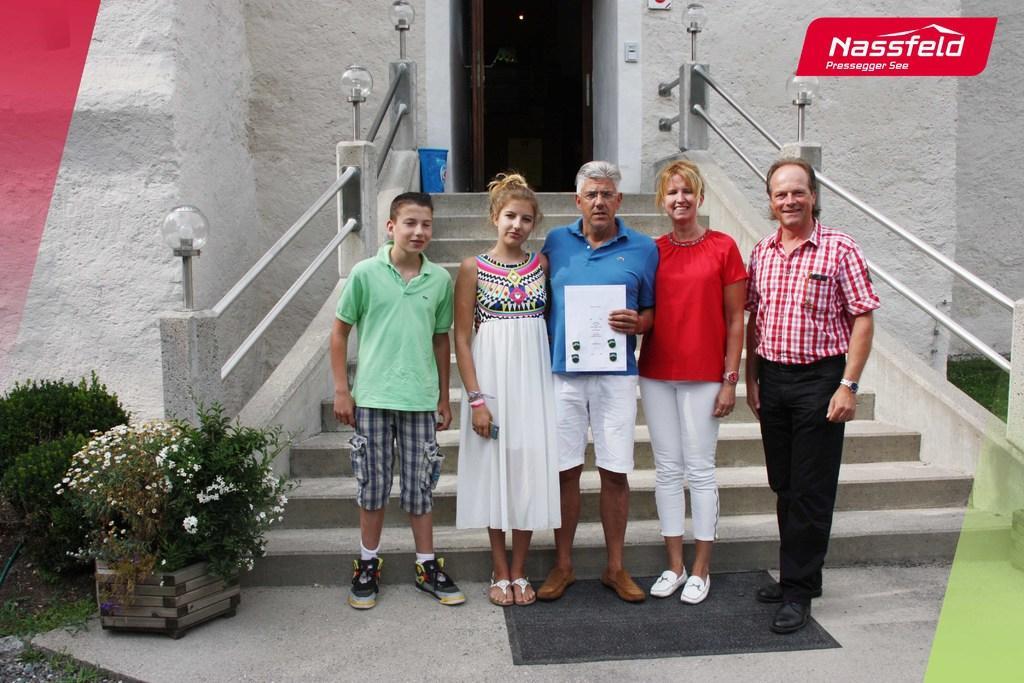Please provide a concise description of this image. In this picture we can see there are five people standing on the floor and a man is holding a paper. Behind the people there are steps, a door and a wall. On the left side of the people there are plants and on the image there is a watermark. 